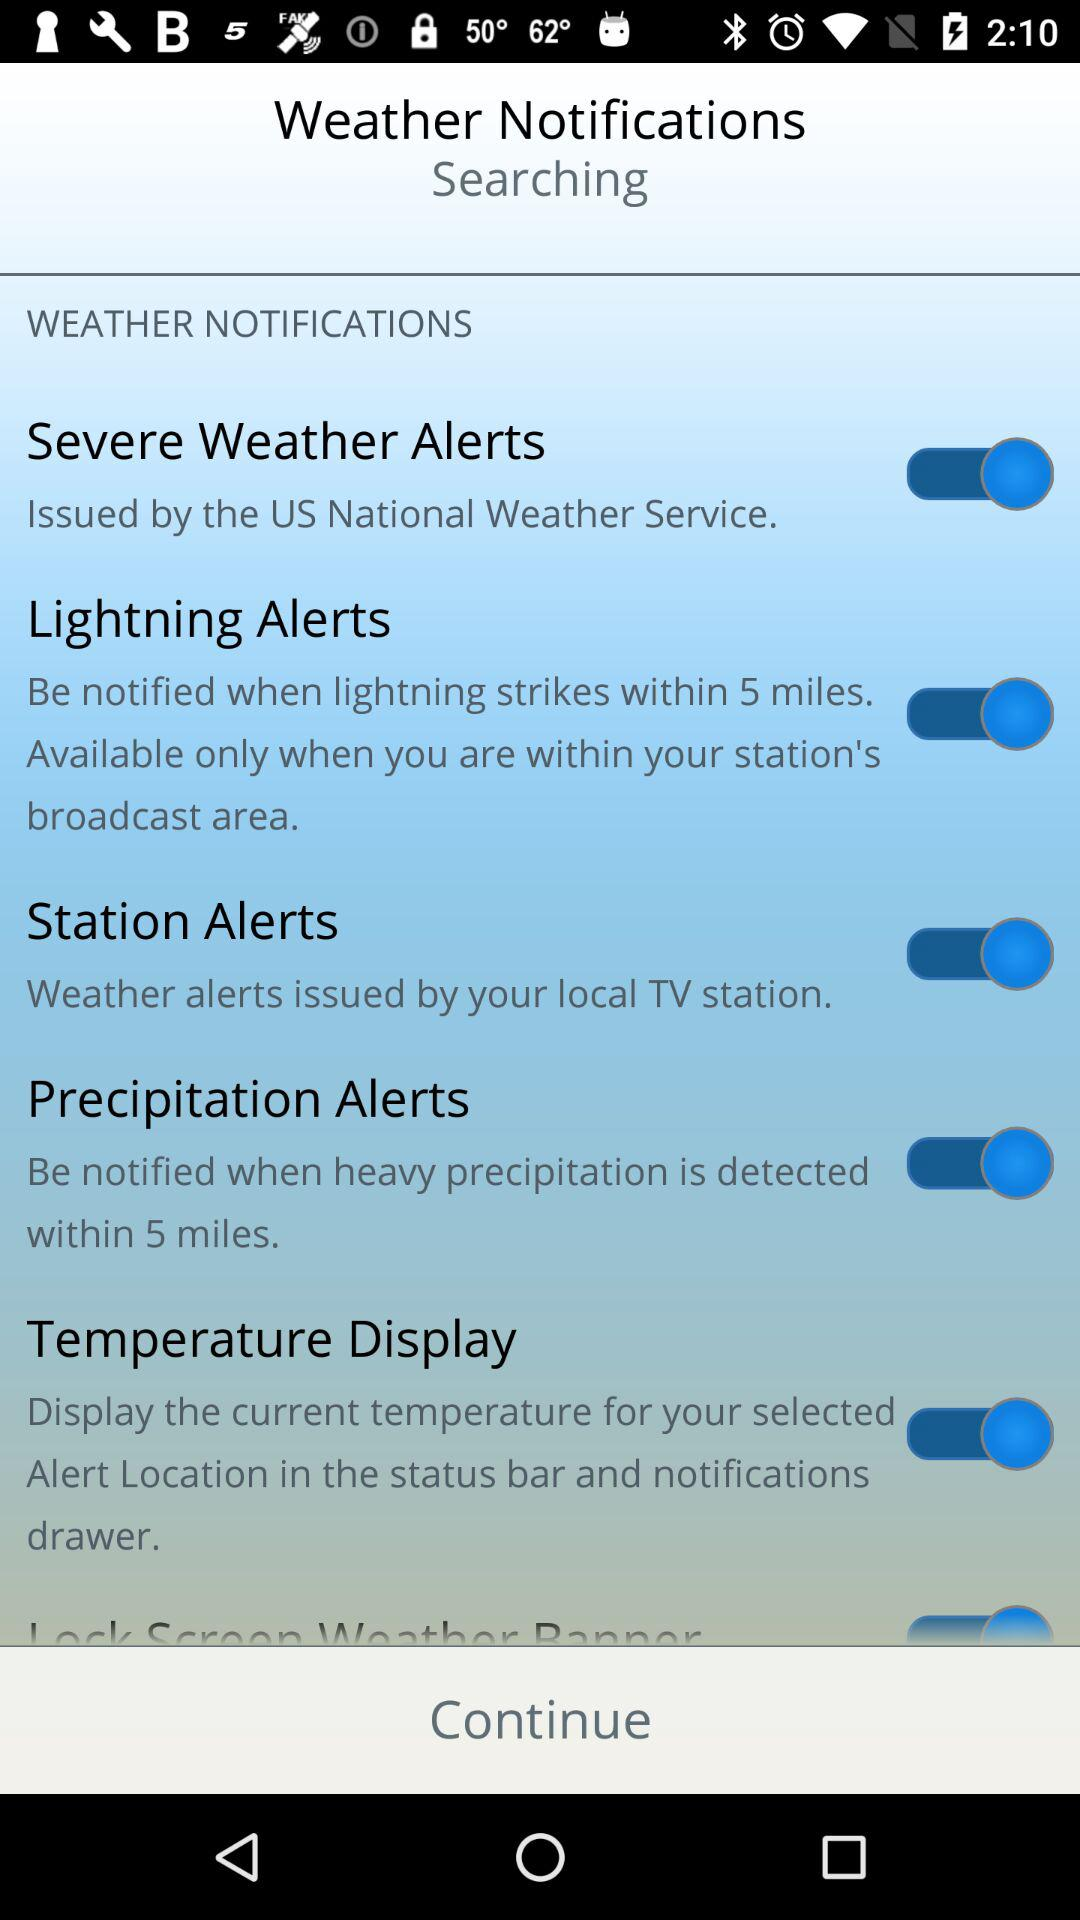Who issues severe weather alerts? Severe weather alerts are issued by the US National Weather Service. 